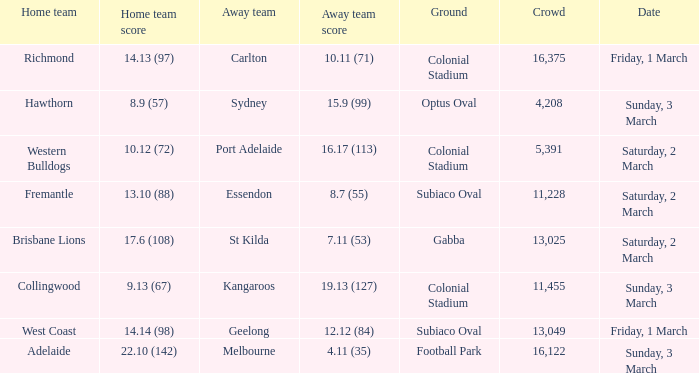What was the ground for away team sydney? Optus Oval. 